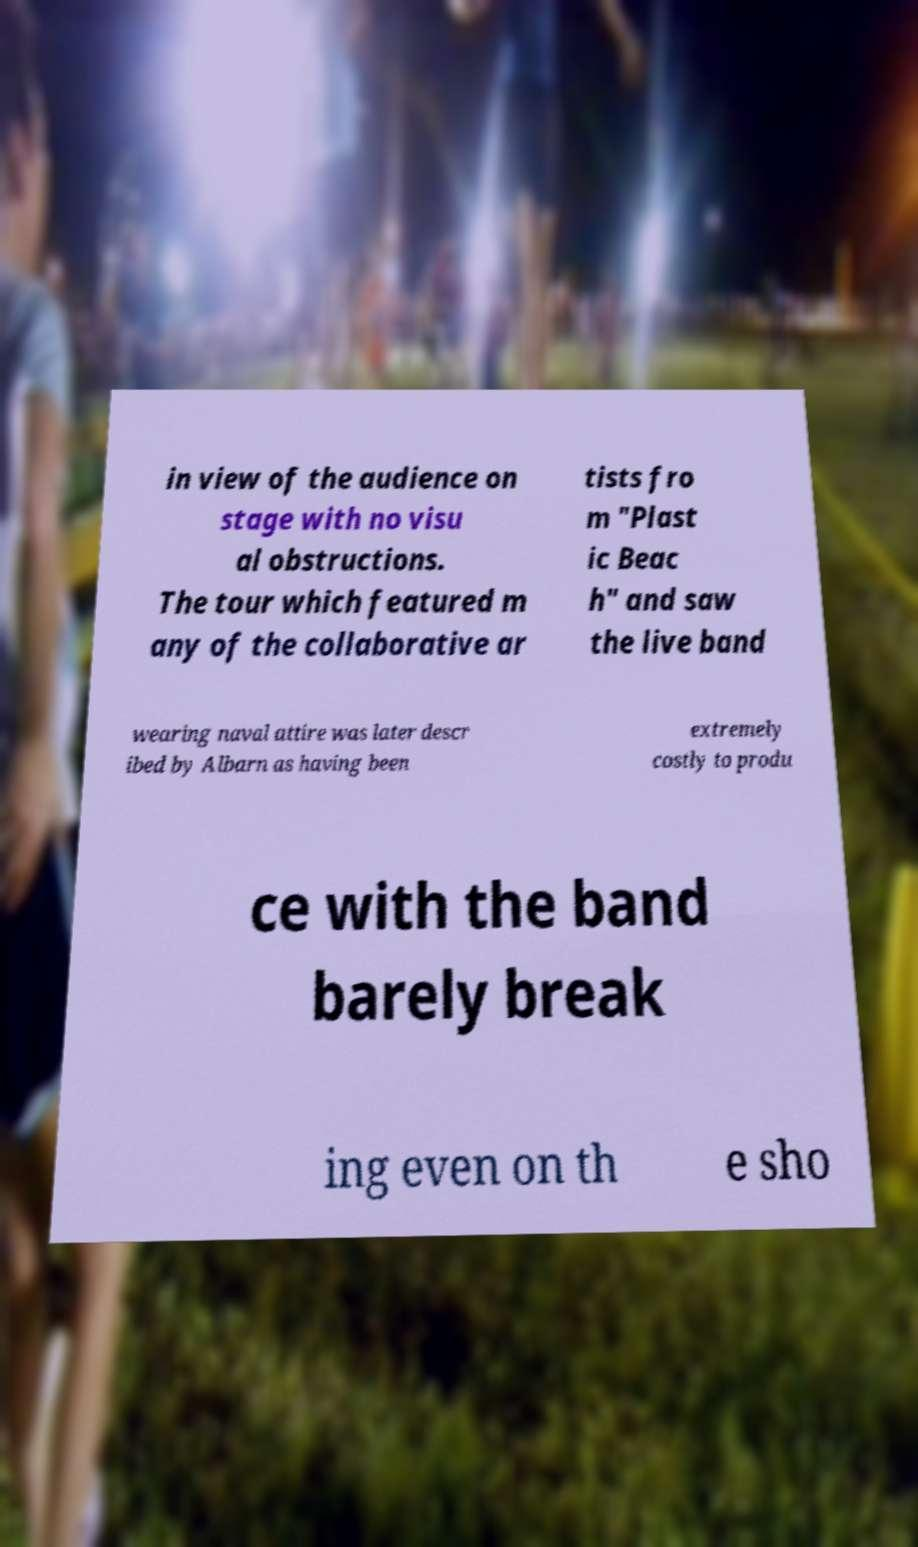Please read and relay the text visible in this image. What does it say? in view of the audience on stage with no visu al obstructions. The tour which featured m any of the collaborative ar tists fro m "Plast ic Beac h" and saw the live band wearing naval attire was later descr ibed by Albarn as having been extremely costly to produ ce with the band barely break ing even on th e sho 